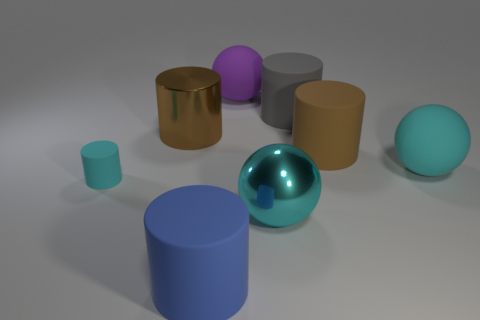The other brown thing that is the same size as the brown matte thing is what shape?
Offer a terse response. Cylinder. Are there an equal number of gray matte objects that are in front of the small cyan cylinder and shiny cylinders to the right of the large cyan rubber sphere?
Provide a succinct answer. Yes. Is there any other thing that has the same shape as the big cyan rubber object?
Your answer should be very brief. Yes. Are the brown cylinder that is right of the big purple sphere and the gray thing made of the same material?
Provide a short and direct response. Yes. There is a purple sphere that is the same size as the gray cylinder; what is it made of?
Keep it short and to the point. Rubber. What number of other objects are there of the same material as the tiny cyan cylinder?
Give a very brief answer. 5. There is a gray object; is it the same size as the cyan ball that is on the right side of the shiny ball?
Offer a terse response. Yes. Are there fewer gray things in front of the big blue matte object than cyan metal objects to the left of the purple object?
Give a very brief answer. No. There is a cyan object right of the large brown matte object; what is its size?
Provide a succinct answer. Large. Do the blue matte thing and the brown rubber cylinder have the same size?
Offer a terse response. Yes. 